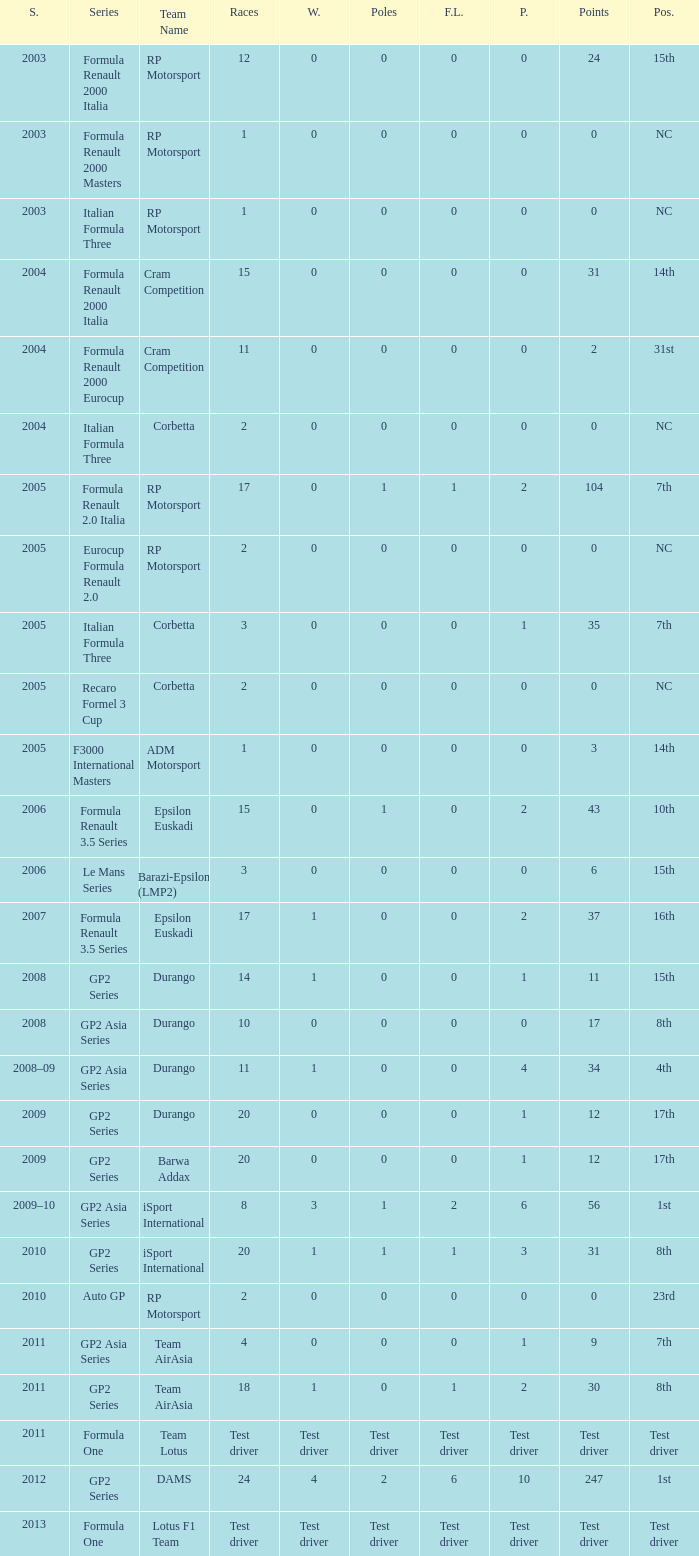What is the number of podiums with 0 wins and 6 points? 0.0. 